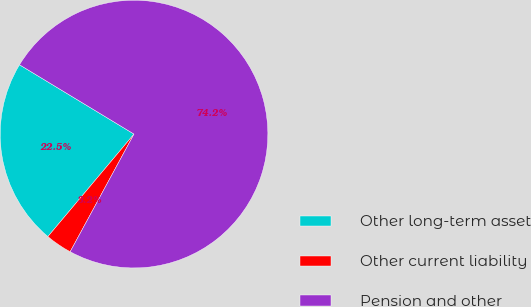Convert chart to OTSL. <chart><loc_0><loc_0><loc_500><loc_500><pie_chart><fcel>Other long-term asset<fcel>Other current liability<fcel>Pension and other<nl><fcel>22.54%<fcel>3.21%<fcel>74.24%<nl></chart> 